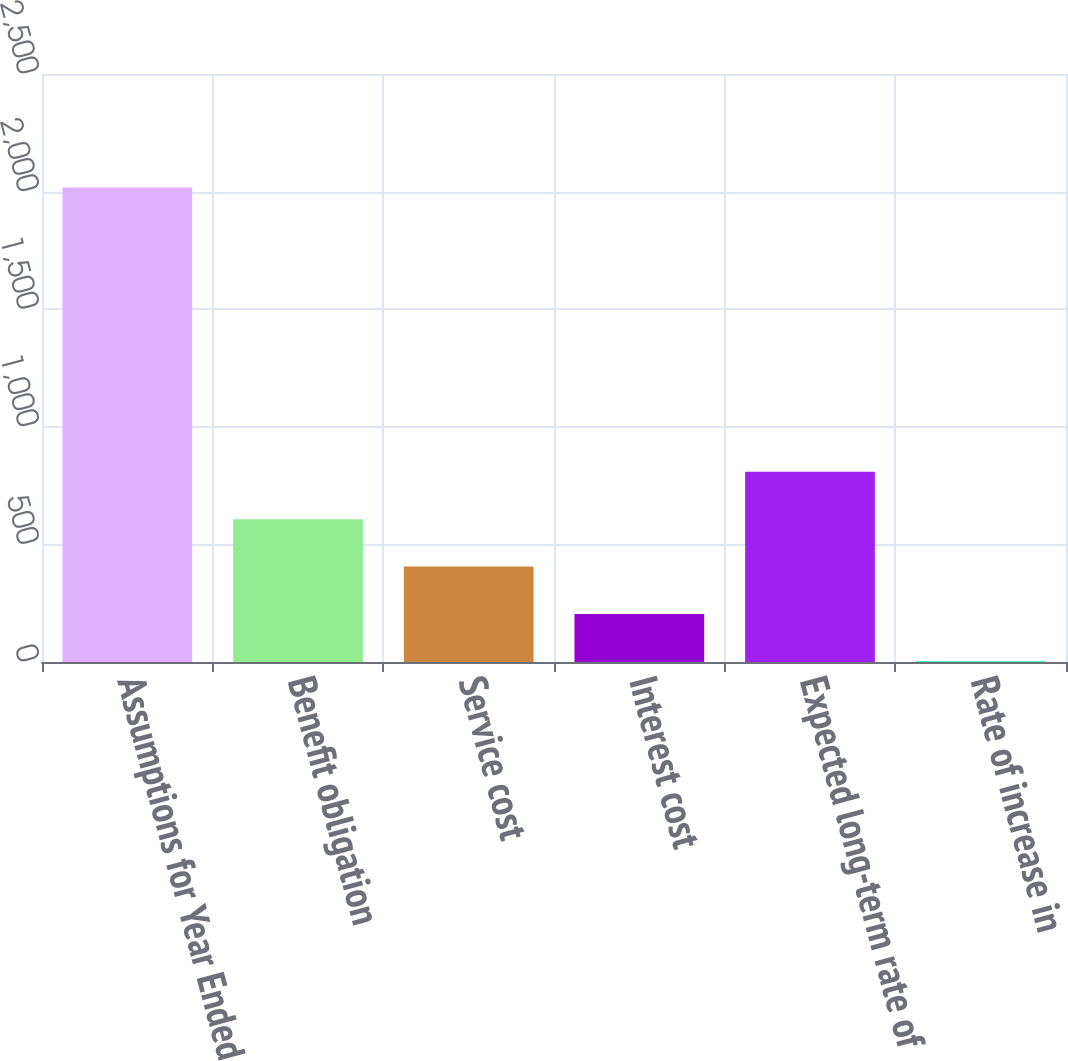Convert chart. <chart><loc_0><loc_0><loc_500><loc_500><bar_chart><fcel>Assumptions for Year Ended<fcel>Benefit obligation<fcel>Service cost<fcel>Interest cost<fcel>Expected long-term rate of<fcel>Rate of increase in<nl><fcel>2017<fcel>607.13<fcel>405.72<fcel>204.31<fcel>808.54<fcel>2.9<nl></chart> 